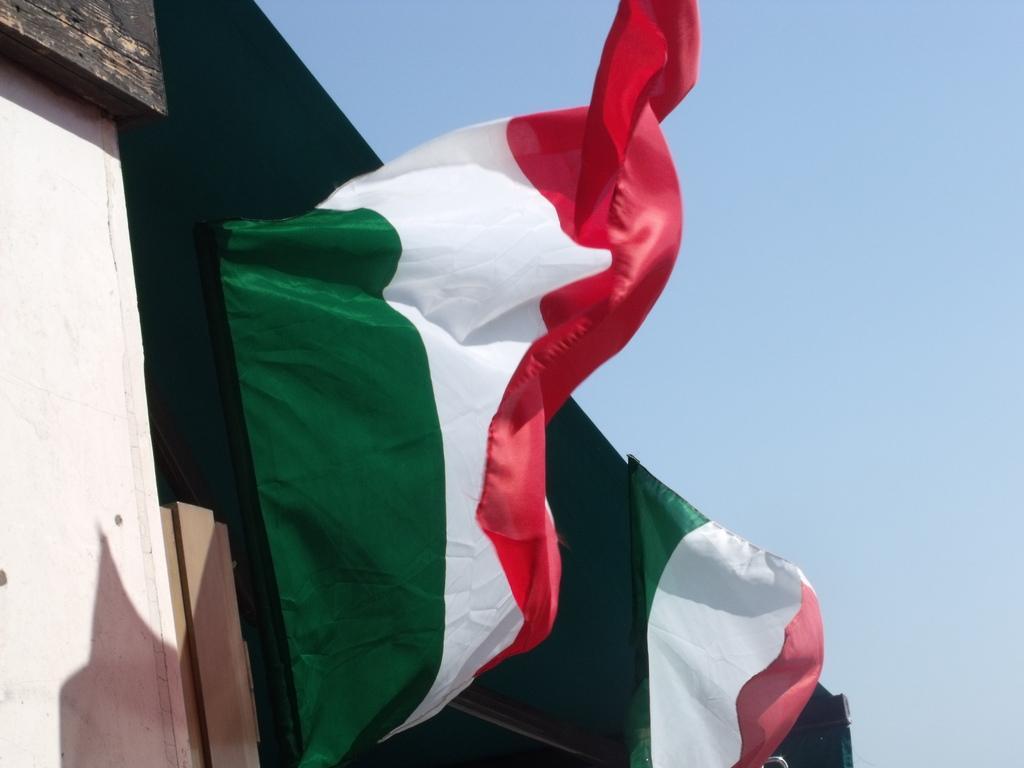Describe this image in one or two sentences. In this image I can see a flag in green, white and red color. Background the sky is in blue color. 